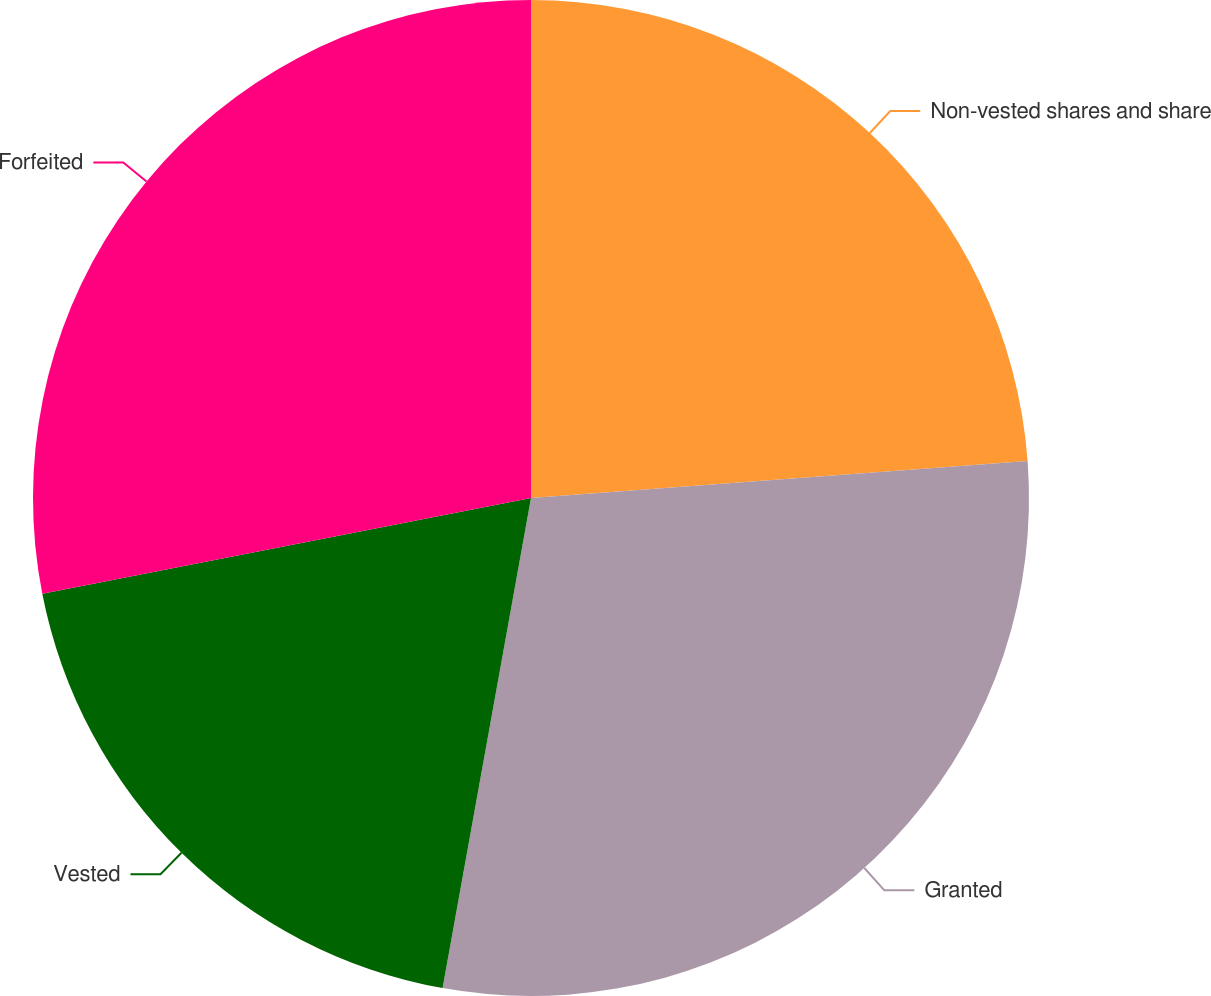Convert chart to OTSL. <chart><loc_0><loc_0><loc_500><loc_500><pie_chart><fcel>Non-vested shares and share<fcel>Granted<fcel>Vested<fcel>Forfeited<nl><fcel>23.82%<fcel>29.02%<fcel>19.08%<fcel>28.08%<nl></chart> 